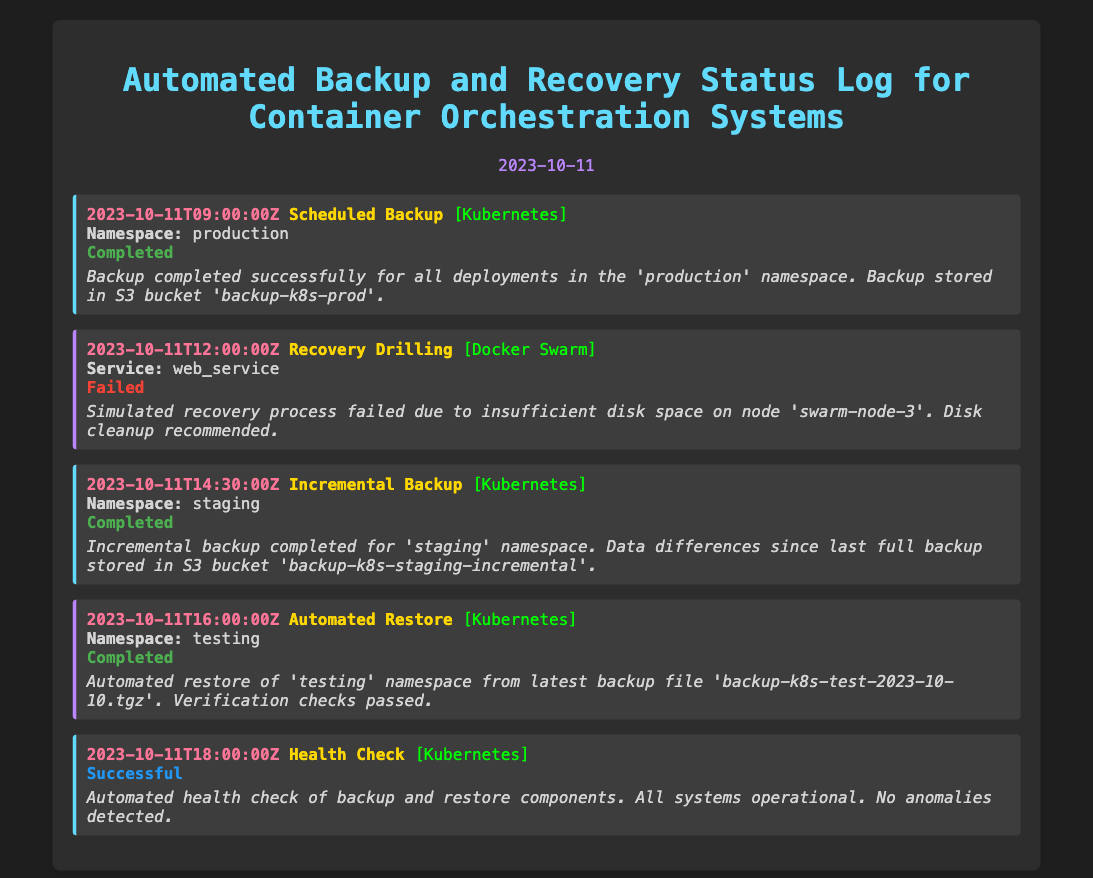What is the date of the log? The log date is prominently displayed in the header section of the document.
Answer: 2023-10-11 What is the first operation recorded in the log? The first log entry details the operation scheduled for backup.
Answer: Scheduled Backup What system is mentioned in the second log entry? The second log entry specifies the system involved in the recovery drilling operation.
Answer: Docker Swarm What was the status of the incremental backup in the log? The status indicates whether the backup operation was successful or not.
Answer: Completed How many operations were recorded in the log? The total number of log entries corresponds to the number of operations listed.
Answer: 5 What issue caused the failure in the recovery drilling operation? The details in the log entry explain the reason for the failure.
Answer: Insufficient disk space Which namespace was involved in the automated restore operation? The specific namespace associated with the restore operation is mentioned in the log.
Answer: testing What was the timestamp of the health check operation? The log provides a timestamp that marks when the health check occurred.
Answer: 2023-10-11T18:00:00Z 